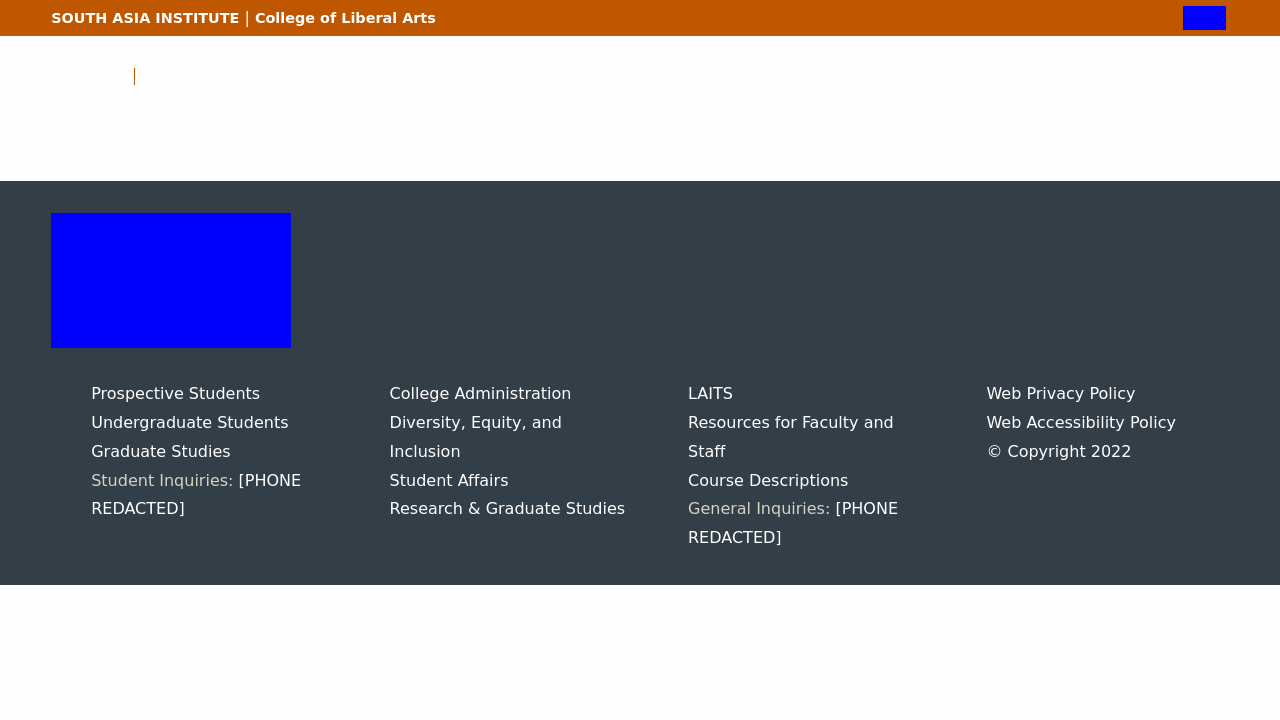What could be the purpose of the phone number listings in the different sections of the image? The inclusion of phone numbers in these sections suggests a design choice aimed at improving user engagement and providing direct lines of communication for prospective and current students, as well as faculty. It serves practical purposes by providing immediate contact points for inquiries related to specific needs such as admission details, existing student support, and research opportunities. How does this approach benefit the university? This approach benefits the university by fostering a more welcoming and supportive environment. It likely increases the likelihood of prospective students applying by lowering barriers to gathering information. For current students and staff, it enhances the ability to get quick resolutions to administrative or academic concerns, which can improve overall satisfaction and the functioning of university services. 